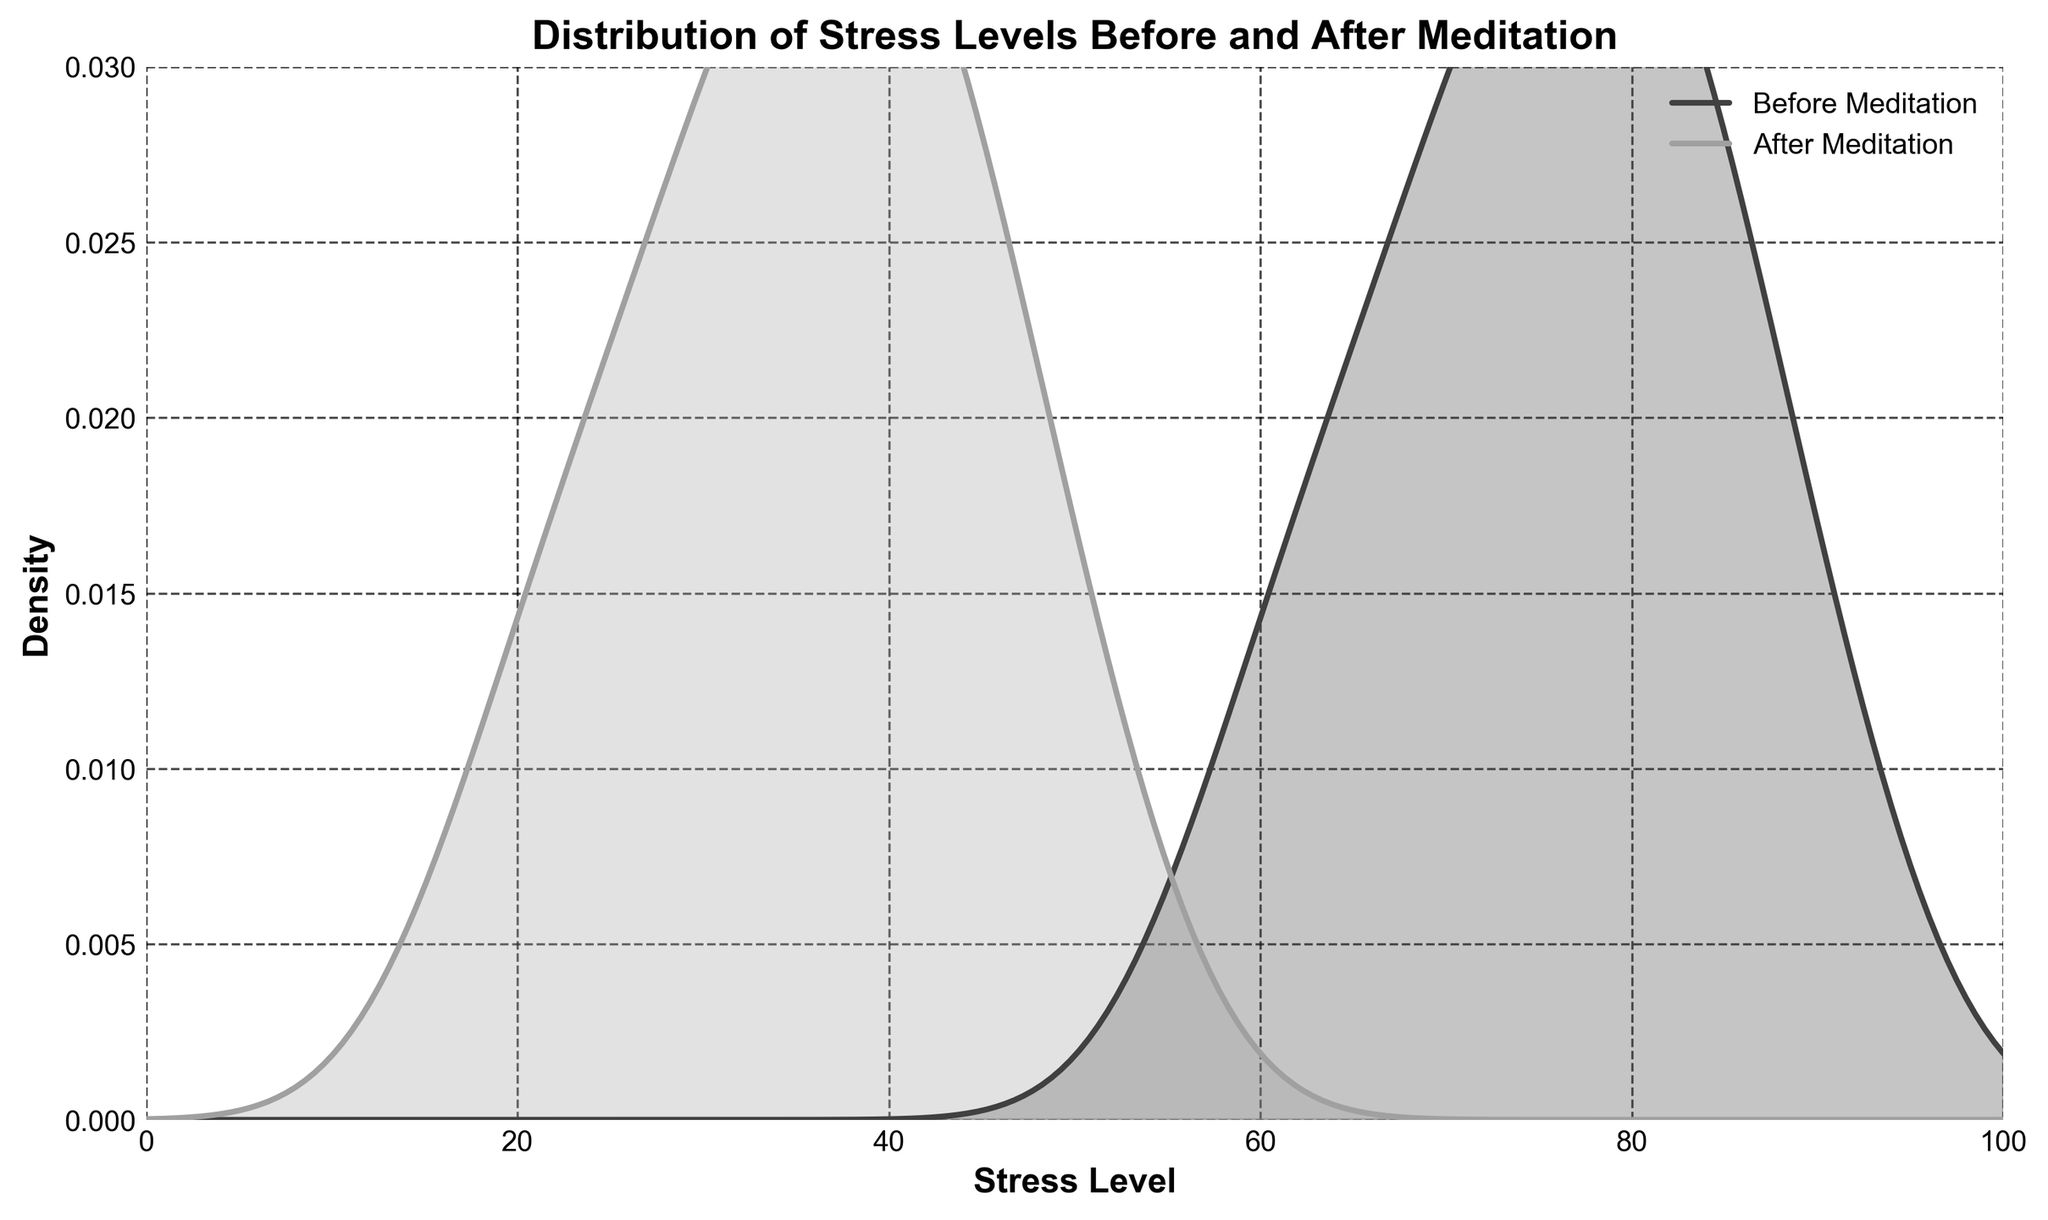What is the title of the figure? The title of the figure is displayed at the top and usually summarizes the content of the plot. Here, it says "Distribution of Stress Levels Before and After Meditation".
Answer: Distribution of Stress Levels Before and After Meditation What are the labels on the x and y axes? The labels on the axes describe what the axes represent. The x-axis is labeled "Stress Level" and the y-axis is labeled "Density".
Answer: Stress Level and Density What range of stress levels does the x-axis cover? The x-axis extends from the minimum to the maximum stress levels displayed. The range of the x-axis is from 0 to 100.
Answer: 0 to 100 What colors are used to represent the stress levels before and after meditation? The plot uses different colors to differentiate the groups. The stress levels before meditation are represented with a darker gray, while after meditation they are shown with a lighter gray.
Answer: Dark gray and light gray Which density curve is higher at a stress level of 30? At a specific stress level, the height of the density curves can be compared. The height of the density curve for "After Meditation" is noticeably higher than "Before Meditation" at a stress level of 30.
Answer: After Meditation How does the peak height compare before and after meditation? The peaks in density represent the most common stress levels. The peak for "Before Meditation" is higher than the peak for "After Meditation".
Answer: Before Meditation At what approximate stress level does the "Before Meditation" curve reach its peak? Locate the highest point on the "Before Meditation" curve and note the x-value at this point. The "Before Meditation" curve peaks around a stress level of 75.
Answer: 75 Based on the plot, did meditation sessions generally reduce stress levels? To determine the effect, compare the stress level distributions before and after meditation. The density curve for "After Meditation" shifts to the left (lower stress levels), indicating a reduction in stress levels.
Answer: Yes What visual elements indicate that gridlines are present in this plot? Gridlines contribute to the readability of a plot by providing reference lines. They are visible as faint dashed lines across the background.
Answer: Dashed lines across the background What is the range of densities covered on the y-axis? Check the vertical extent of the plot to identify the minimum and maximum densities shown. The range on the y-axis is from 0 to 0.03.
Answer: 0 to 0.03 